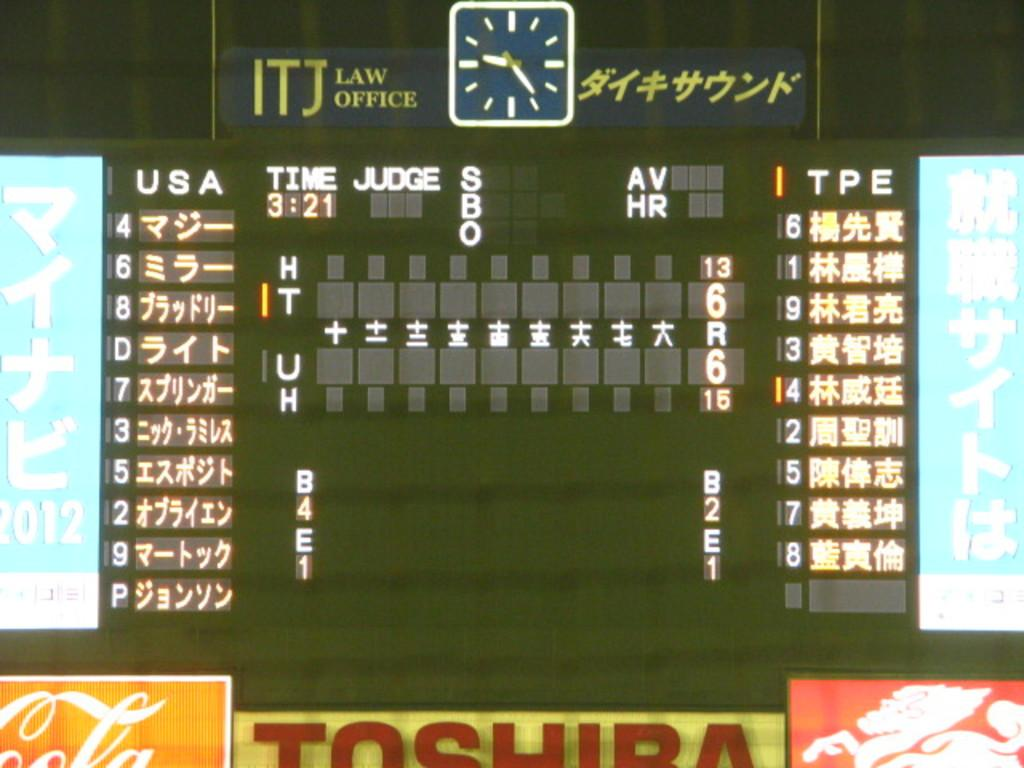<image>
Share a concise interpretation of the image provided. a Toshiba advertisement that is at a game event 